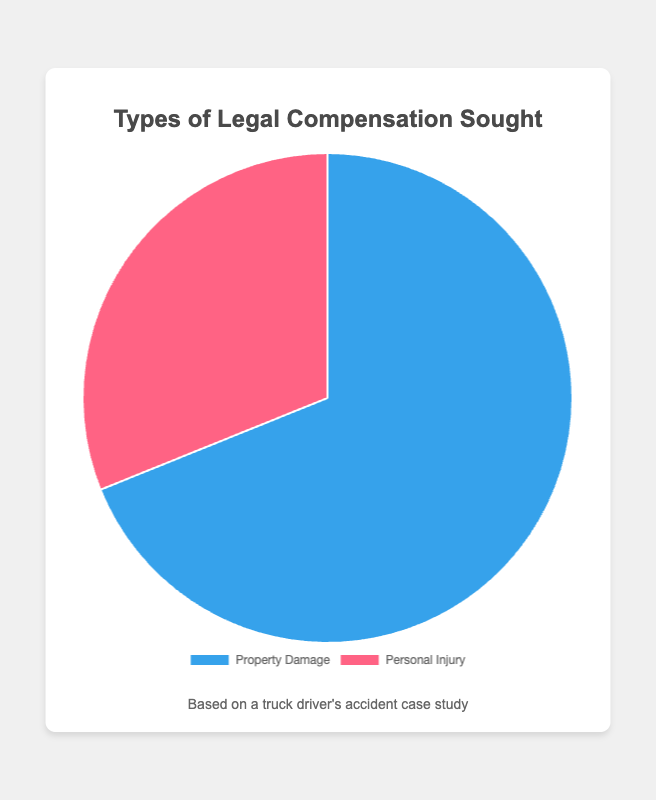what type of legal compensation sought has the higher value? To identify which type of legal compensation sought has the higher value, look at the data values for 'Property Damage' and 'Personal Injury'. 'Property Damage' has a value of 62000, while 'Personal Injury' has a value of 28000. Therefore, 'Property Damage' has the higher value.
Answer: Property Damage what is the total amount of legal compensation sought? Add the values for both types of legal compensation sought: 62000 (Property Damage) + 28000 (Personal Injury). This gives a total of 90000.
Answer: 90000 what proportion of the total compensation is for property damage? To find the proportion of total compensation for 'Property Damage', divide the 'Property Damage' value by the total compensation and then multiply by 100: (62000 / 90000) * 100 ≈ 68.89%.
Answer: 68.89% how much more is sought for property damage compared to personal injury? To determine how much more is sought for 'Property Damage' compared to 'Personal Injury', subtract the value for 'Personal Injury' from the value for 'Property Damage': 62000 - 28000 = 34000.
Answer: 34000 if the total amount sought increases by 10%, what will be the new total? First, calculate 10% of the total amount: 10% of 90000 is 9000. Then, add this to the original total: 90000 + 9000 = 99000.
Answer: 99000 what percentage less is sought for personal injury compared to property damage? To find the percentage less sought for 'Personal Injury' compared to 'Property Damage', first find the difference: 62000 - 28000 = 34000. Then, divide this difference by the 'Property Damage' value and multiply by 100: (34000 / 62000) * 100 ≈ 54.84%.
Answer: 54.84% if the compensation for personal injury is doubled, will it exceed the amount sought for property damage? Doubling the compensation for 'Personal Injury' gives 28000 * 2 = 56000. Since 56000 is less than 62000 (the amount sought for 'Property Damage'), it will not exceed the amount sought for 'Property Damage'.
Answer: No what visual color represents the category with the lower compensation amount? Observe the colors associated with each compensation type. 'Personal Injury' has the lower amount (28000) and is represented by the red color.
Answer: Red 